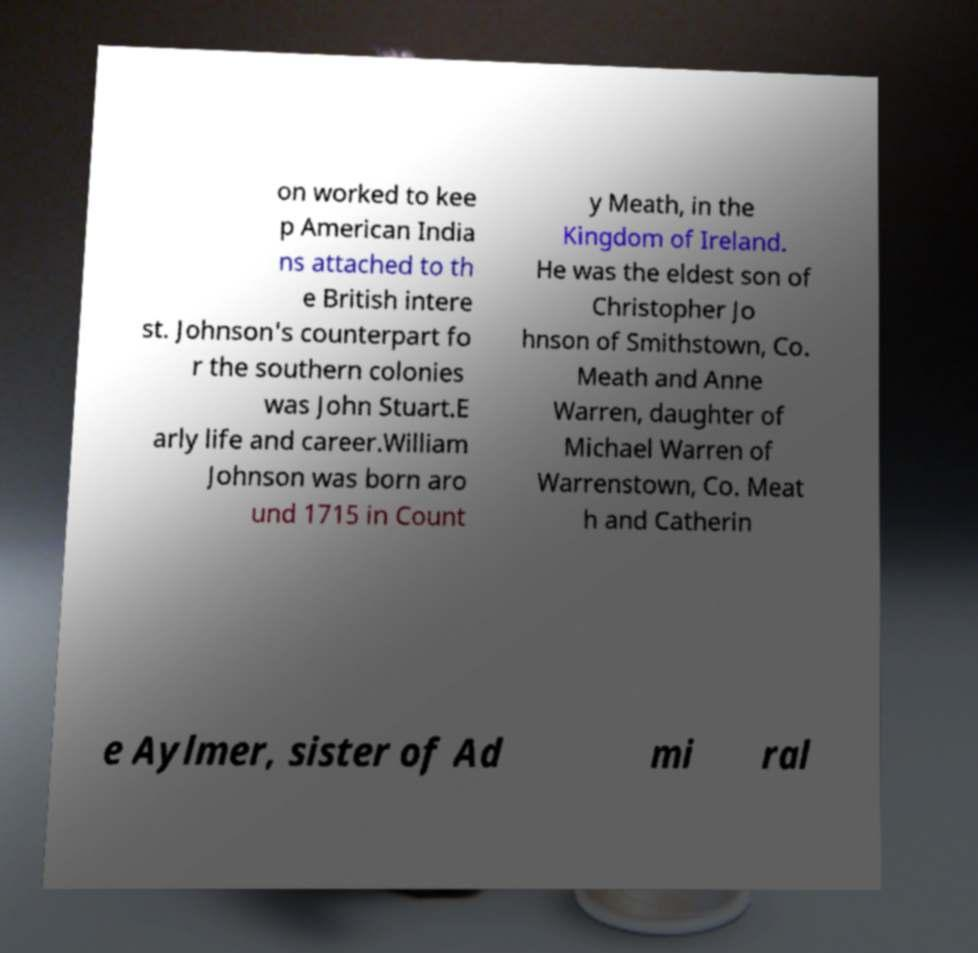Please read and relay the text visible in this image. What does it say? on worked to kee p American India ns attached to th e British intere st. Johnson's counterpart fo r the southern colonies was John Stuart.E arly life and career.William Johnson was born aro und 1715 in Count y Meath, in the Kingdom of Ireland. He was the eldest son of Christopher Jo hnson of Smithstown, Co. Meath and Anne Warren, daughter of Michael Warren of Warrenstown, Co. Meat h and Catherin e Aylmer, sister of Ad mi ral 